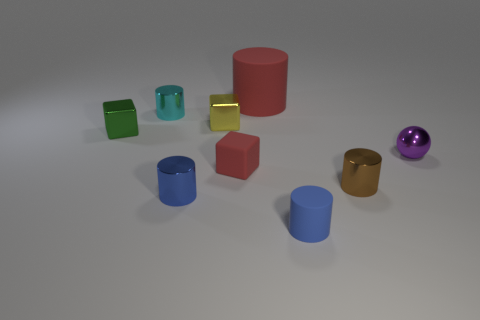Subtract 1 cylinders. How many cylinders are left? 4 Subtract all yellow cylinders. Subtract all gray cubes. How many cylinders are left? 5 Add 1 big red rubber blocks. How many objects exist? 10 Subtract all cubes. How many objects are left? 6 Subtract 0 cyan spheres. How many objects are left? 9 Subtract all tiny cyan things. Subtract all tiny yellow metal blocks. How many objects are left? 7 Add 3 small green metal things. How many small green metal things are left? 4 Add 2 tiny red blocks. How many tiny red blocks exist? 3 